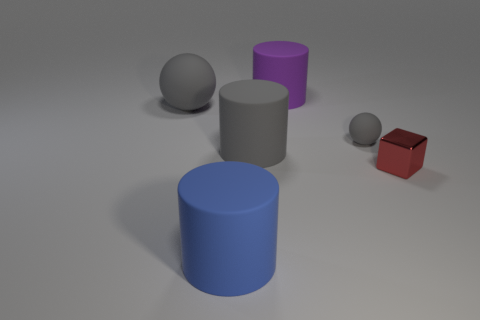Subtract all gray rubber cylinders. How many cylinders are left? 2 Add 3 tiny purple matte objects. How many objects exist? 9 Subtract all blocks. How many objects are left? 5 Subtract all blue cylinders. How many cylinders are left? 2 Subtract all green balls. How many purple cubes are left? 0 Subtract all big red metallic cylinders. Subtract all large blue objects. How many objects are left? 5 Add 2 gray rubber things. How many gray rubber things are left? 5 Add 1 blue rubber objects. How many blue rubber objects exist? 2 Subtract 0 green cylinders. How many objects are left? 6 Subtract 1 spheres. How many spheres are left? 1 